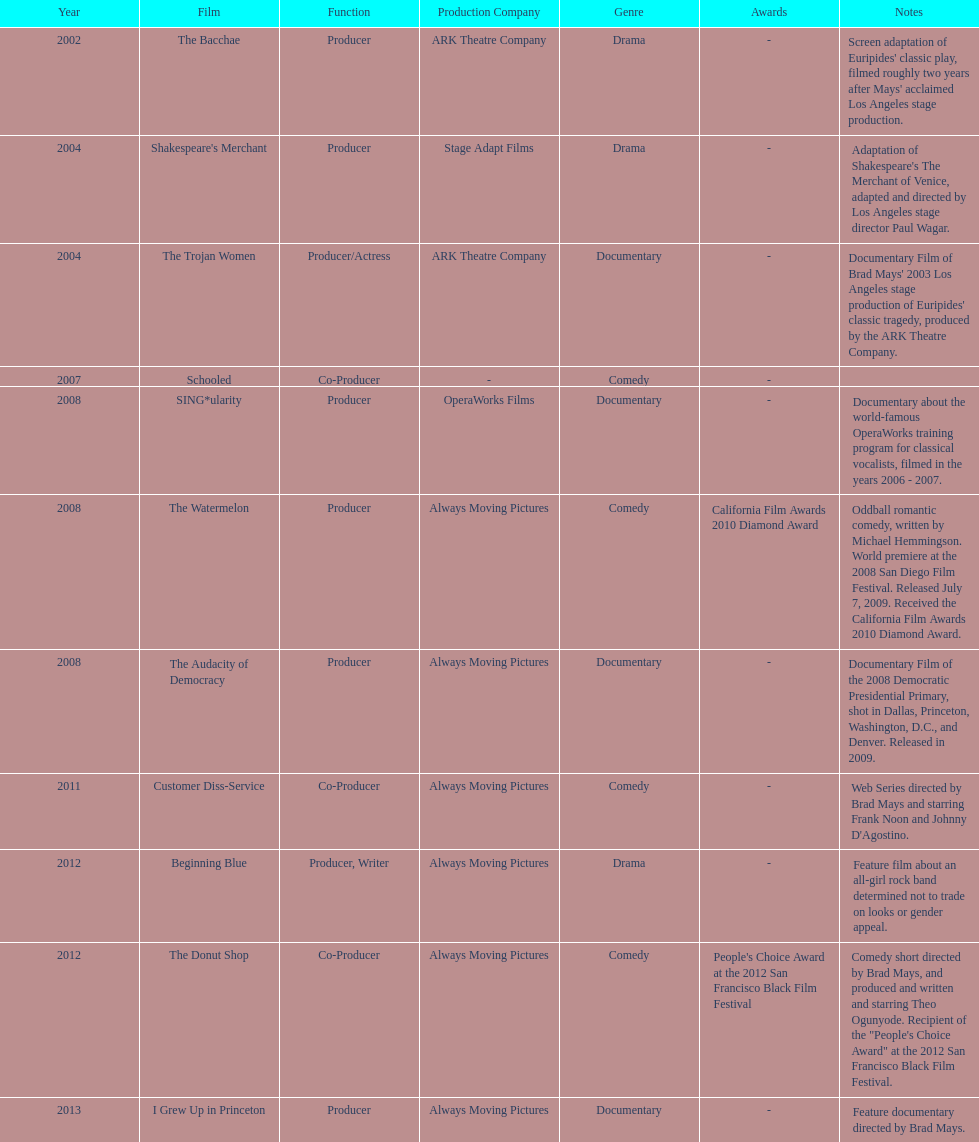Which year was there at least three movies? 2008. 